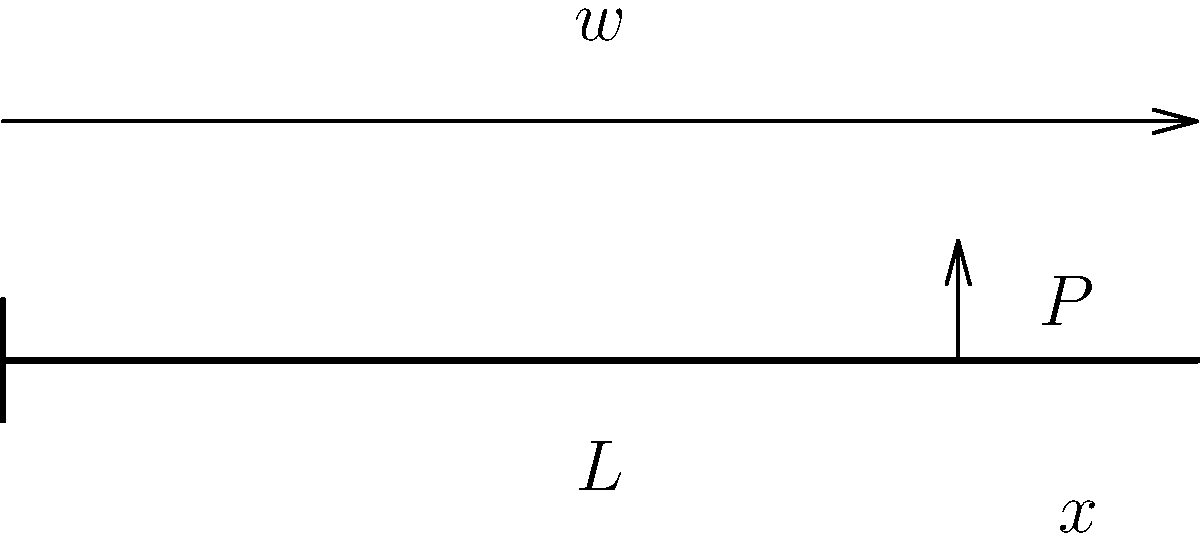A cantilever beam of length $L$ is subjected to a uniformly distributed load $w$ along its entire length and a point load $P$ at a distance $x$ from the free end. Determine the expression for the maximum bending stress $\sigma_{max}$ at the fixed end of the beam in terms of $w$, $P$, $L$, $x$, and the section modulus $Z$. To find the maximum bending stress, we need to follow these steps:

1) Calculate the reaction moment at the fixed end:
   The moment due to the distributed load: $M_w = \frac{wL^2}{2}$
   The moment due to the point load: $M_P = P(L-x)$
   Total moment: $M_{total} = \frac{wL^2}{2} + P(L-x)$

2) The maximum bending stress occurs at the fixed end and is given by:
   $$\sigma_{max} = \frac{M_{total}}{Z}$$

3) Substituting the total moment:
   $$\sigma_{max} = \frac{\frac{wL^2}{2} + P(L-x)}{Z}$$

4) This can be simplified to:
   $$\sigma_{max} = \frac{wL^2 + 2P(L-x)}{2Z}$$

This expression gives the maximum bending stress at the fixed end of the cantilever beam in terms of the given parameters.
Answer: $$\sigma_{max} = \frac{wL^2 + 2P(L-x)}{2Z}$$ 